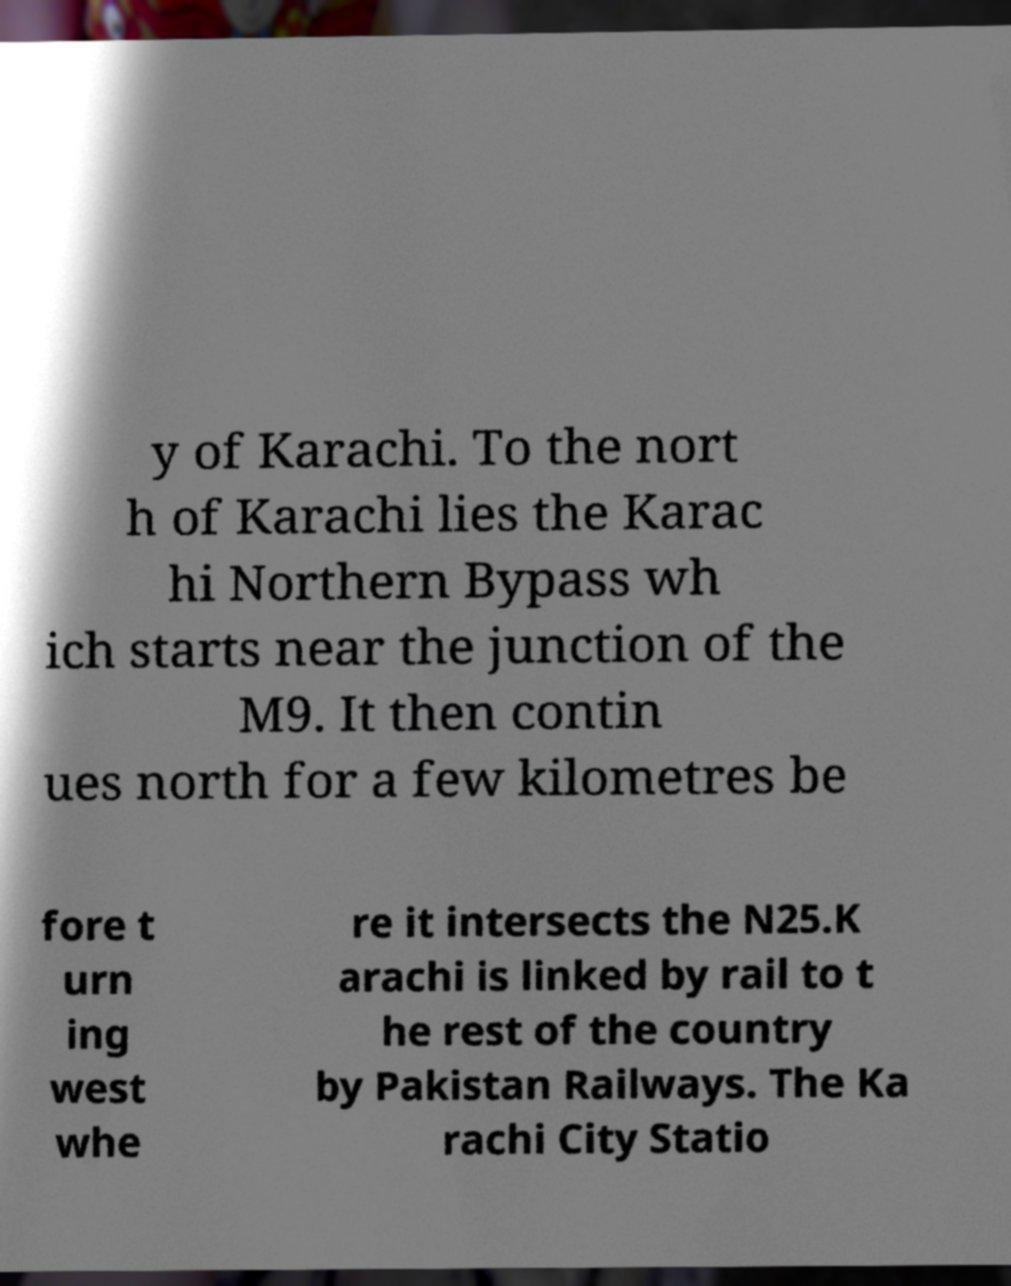Can you accurately transcribe the text from the provided image for me? y of Karachi. To the nort h of Karachi lies the Karac hi Northern Bypass wh ich starts near the junction of the M9. It then contin ues north for a few kilometres be fore t urn ing west whe re it intersects the N25.K arachi is linked by rail to t he rest of the country by Pakistan Railways. The Ka rachi City Statio 